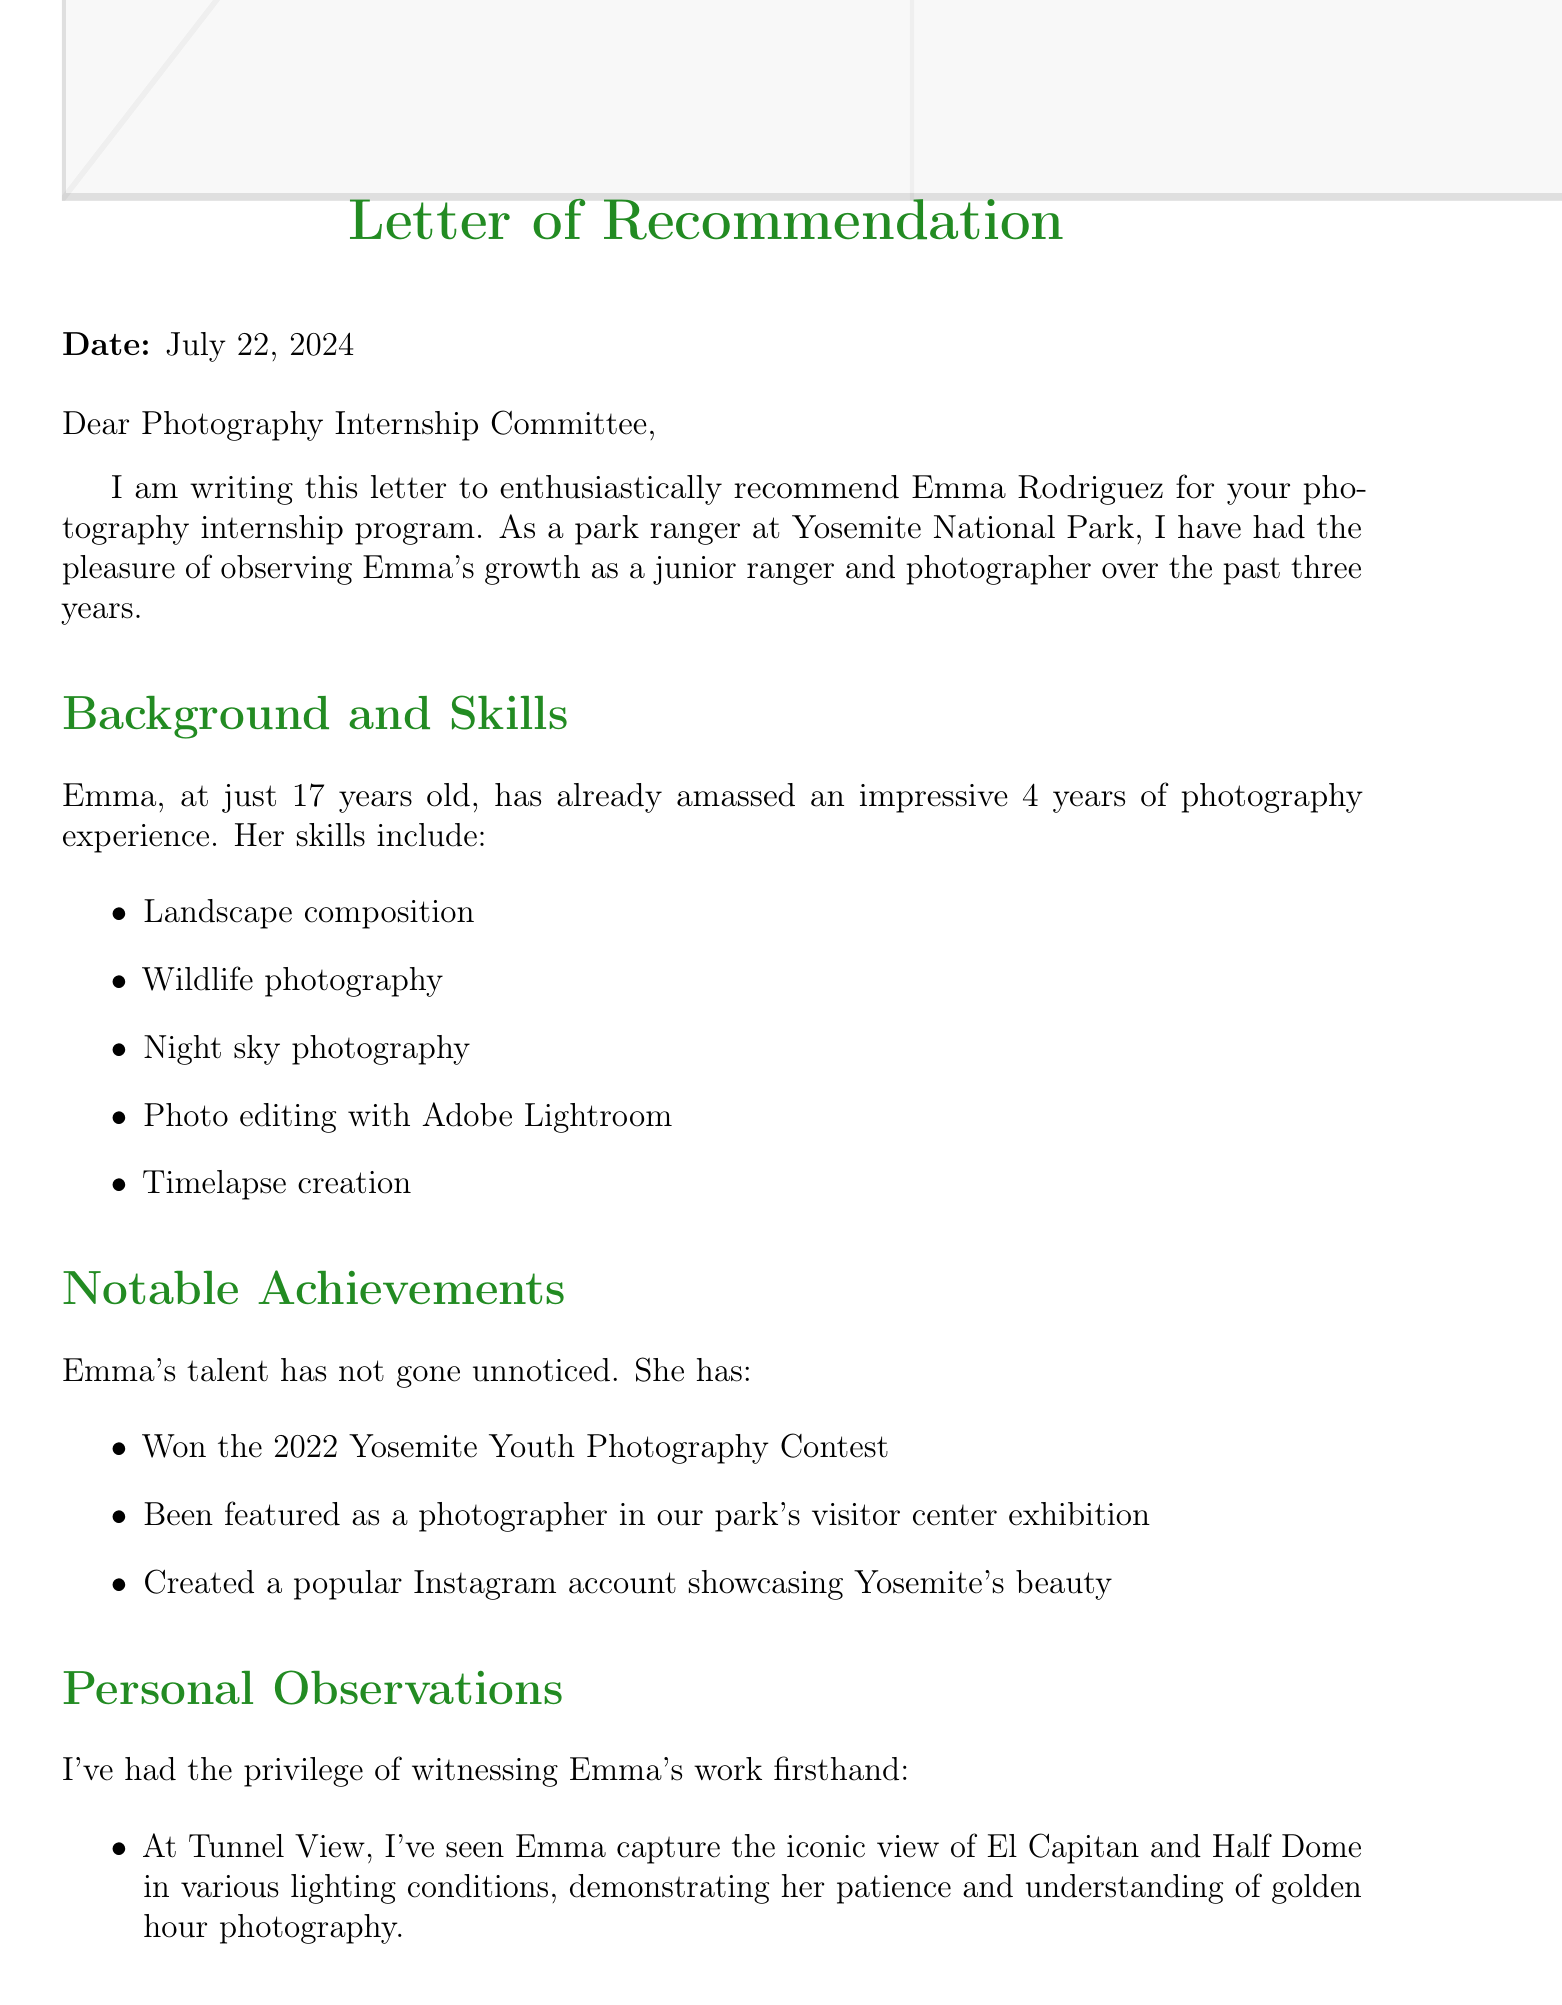What is the name of the junior ranger? The name mentioned in the document is Emma Rodriguez.
Answer: Emma Rodriguez How many years has Emma been a junior ranger? The document states that Emma has been a junior ranger for 3 years.
Answer: 3 years What is Emma's age? The document specifies that Emma is 17 years old.
Answer: 17 What photography contest did Emma win? Emma won the 2022 Yosemite Youth Photography Contest as mentioned in the document.
Answer: 2022 Yosemite Youth Photography Contest What type of photography did Emma excel at according to the observations? The document highlights Emma's exceptional night sky photography.
Answer: Night sky photography What park is Emma currently a junior ranger at? The document indicates that Emma is a junior ranger at Yosemite National Park.
Answer: Yosemite National Park Which internship location focuses on nature storytelling techniques? The document mentions National Geographic as the location focused on nature storytelling techniques.
Answer: National Geographic What is a potential growth area for Emma? The document lists underwater photography in park rivers and lakes as a potential growth area for her.
Answer: Underwater photography Who is the letter addressed to? The letter is addressed to the Photography Internship Committee.
Answer: Photography Internship Committee 